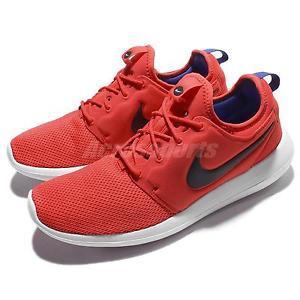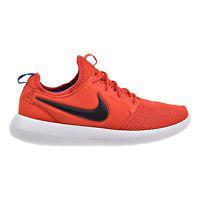The first image is the image on the left, the second image is the image on the right. For the images shown, is this caption "The pair of shoes is on the left of the single shoe." true? Answer yes or no. Yes. The first image is the image on the left, the second image is the image on the right. Assess this claim about the two images: "Left image shows a pair of orange sneakers, and right image shows just one sneaker.". Correct or not? Answer yes or no. Yes. 